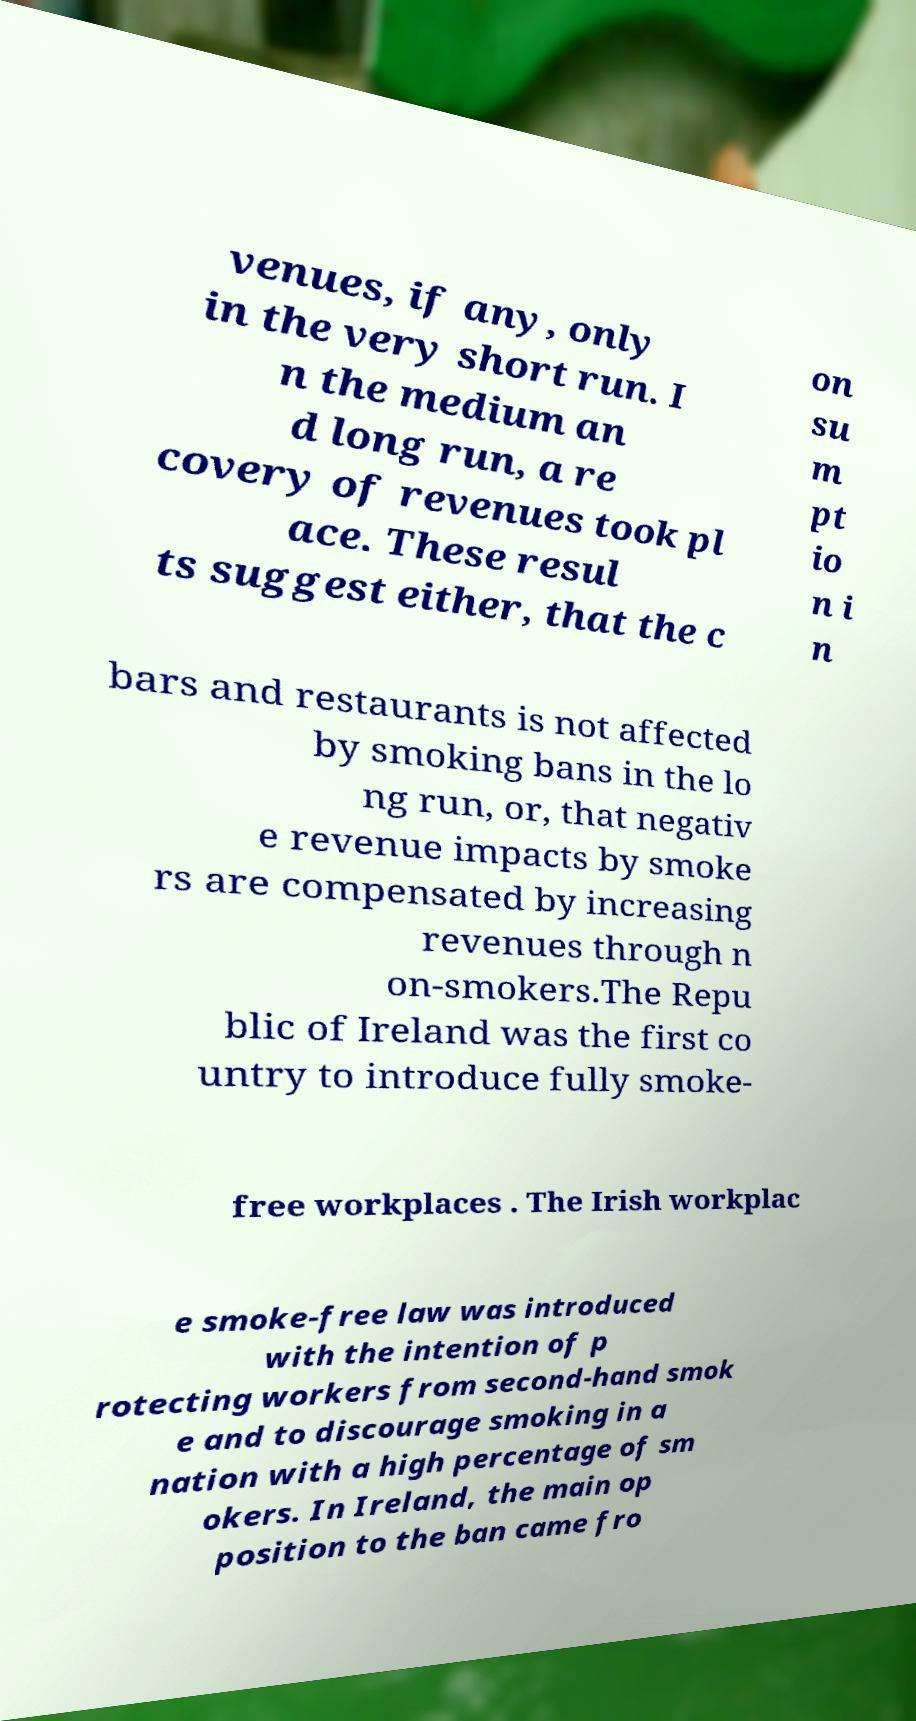What messages or text are displayed in this image? I need them in a readable, typed format. venues, if any, only in the very short run. I n the medium an d long run, a re covery of revenues took pl ace. These resul ts suggest either, that the c on su m pt io n i n bars and restaurants is not affected by smoking bans in the lo ng run, or, that negativ e revenue impacts by smoke rs are compensated by increasing revenues through n on-smokers.The Repu blic of Ireland was the first co untry to introduce fully smoke- free workplaces . The Irish workplac e smoke-free law was introduced with the intention of p rotecting workers from second-hand smok e and to discourage smoking in a nation with a high percentage of sm okers. In Ireland, the main op position to the ban came fro 